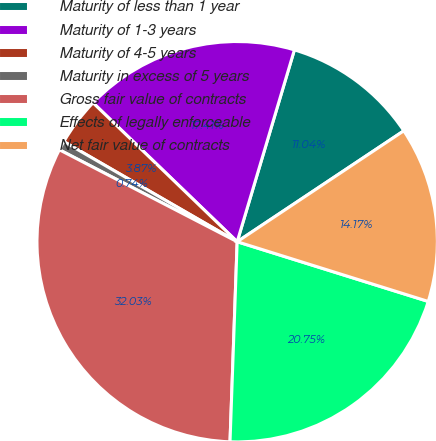Convert chart to OTSL. <chart><loc_0><loc_0><loc_500><loc_500><pie_chart><fcel>Maturity of less than 1 year<fcel>Maturity of 1-3 years<fcel>Maturity of 4-5 years<fcel>Maturity in excess of 5 years<fcel>Gross fair value of contracts<fcel>Effects of legally enforceable<fcel>Net fair value of contracts<nl><fcel>11.04%<fcel>17.41%<fcel>3.87%<fcel>0.74%<fcel>32.03%<fcel>20.75%<fcel>14.17%<nl></chart> 